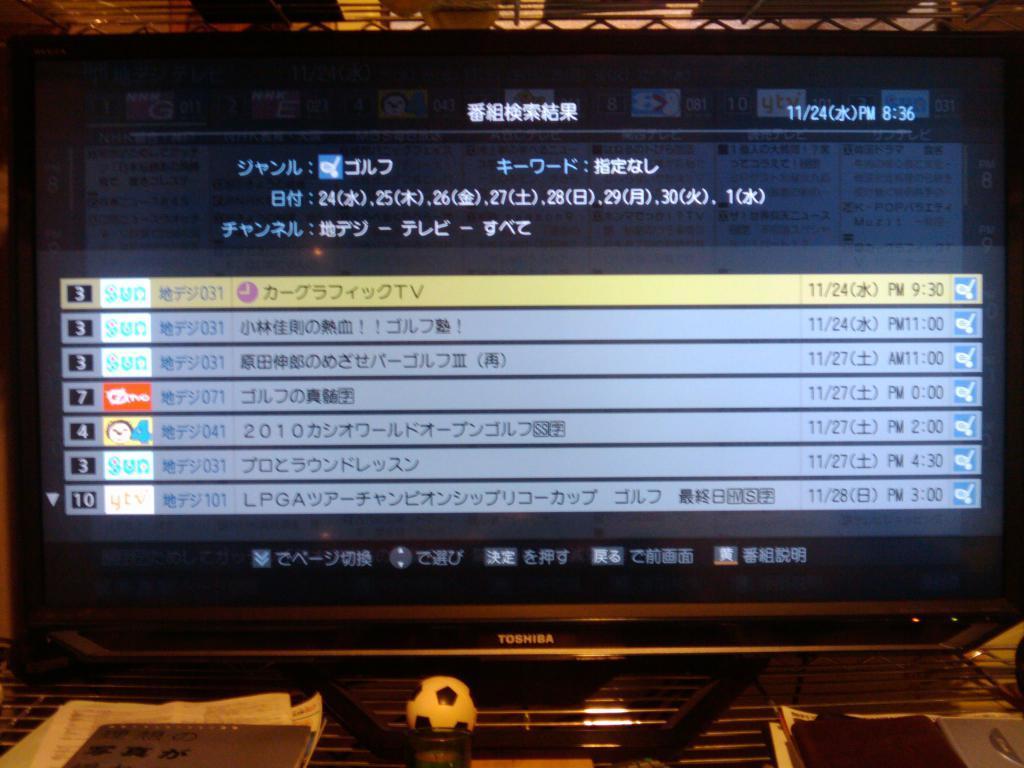Describe this image in one or two sentences. We can see monitor,ball,papers and objects on the table,in this screen we can see some information. 